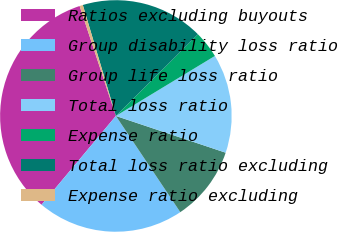Convert chart to OTSL. <chart><loc_0><loc_0><loc_500><loc_500><pie_chart><fcel>Ratios excluding buyouts<fcel>Group disability loss ratio<fcel>Group life loss ratio<fcel>Total loss ratio<fcel>Expense ratio<fcel>Total loss ratio excluding<fcel>Expense ratio excluding<nl><fcel>33.84%<fcel>20.48%<fcel>10.47%<fcel>13.81%<fcel>3.79%<fcel>17.15%<fcel>0.46%<nl></chart> 